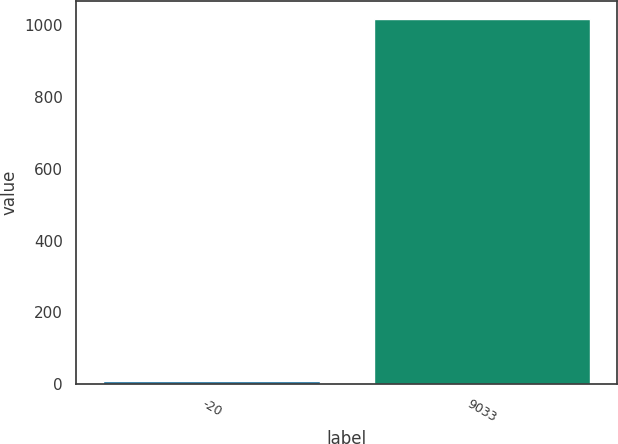Convert chart to OTSL. <chart><loc_0><loc_0><loc_500><loc_500><bar_chart><fcel>-20<fcel>9033<nl><fcel>10<fcel>1016.2<nl></chart> 